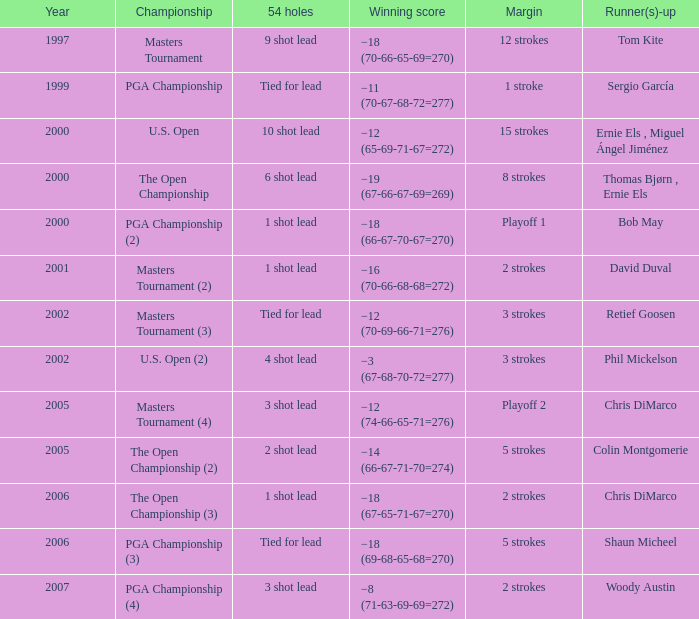What is the difference where phil mickelson ends up as a runner-up? 3 strokes. 